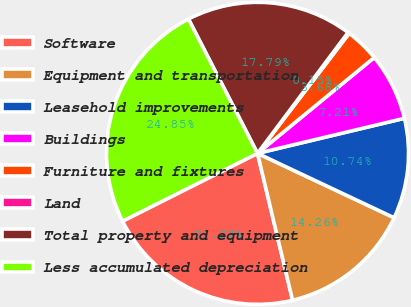Convert chart to OTSL. <chart><loc_0><loc_0><loc_500><loc_500><pie_chart><fcel>Software<fcel>Equipment and transportation<fcel>Leasehold improvements<fcel>Buildings<fcel>Furniture and fixtures<fcel>Land<fcel>Total property and equipment<fcel>Less accumulated depreciation<nl><fcel>21.32%<fcel>14.26%<fcel>10.74%<fcel>7.21%<fcel>3.68%<fcel>0.15%<fcel>17.79%<fcel>24.85%<nl></chart> 